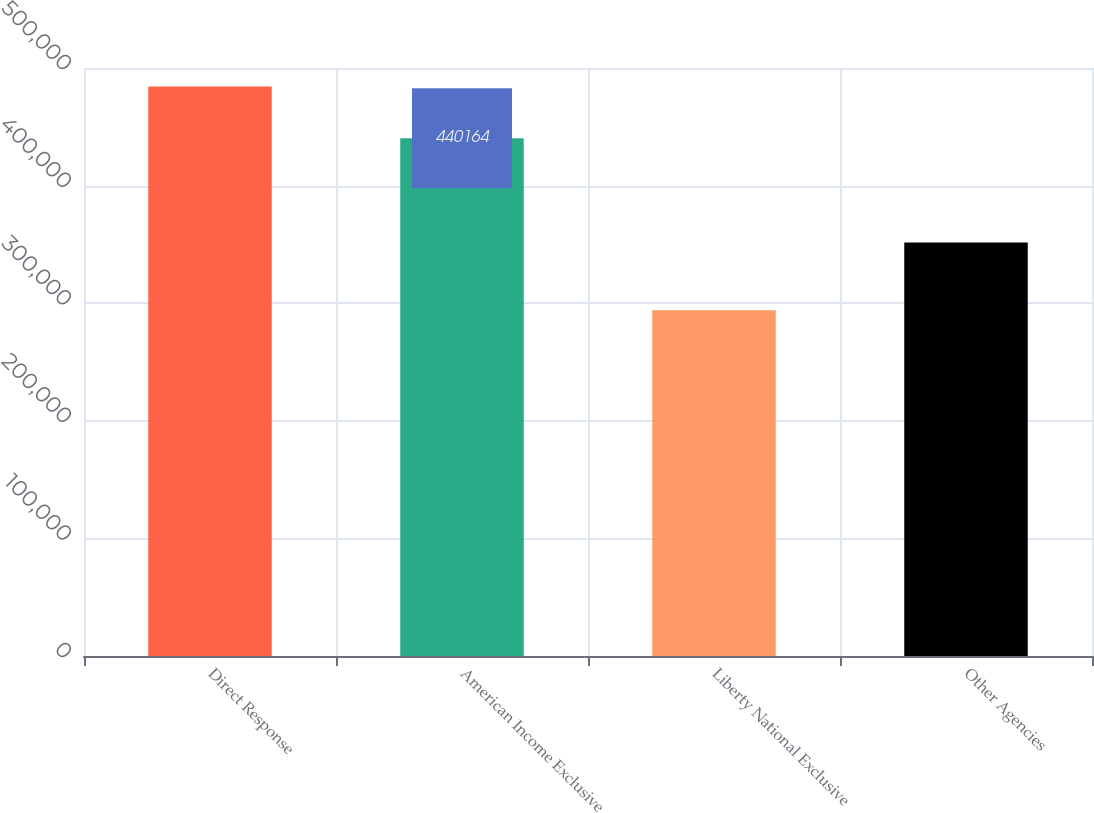<chart> <loc_0><loc_0><loc_500><loc_500><bar_chart><fcel>Direct Response<fcel>American Income Exclusive<fcel>Liberty National Exclusive<fcel>Other Agencies<nl><fcel>484176<fcel>440164<fcel>293936<fcel>351688<nl></chart> 